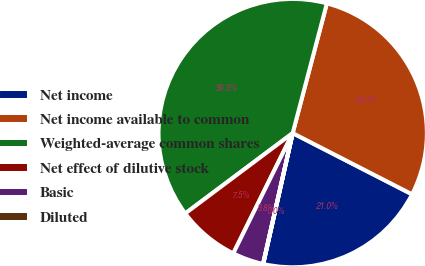Convert chart. <chart><loc_0><loc_0><loc_500><loc_500><pie_chart><fcel>Net income<fcel>Net income available to common<fcel>Weighted-average common shares<fcel>Net effect of dilutive stock<fcel>Basic<fcel>Diluted<nl><fcel>20.98%<fcel>28.44%<fcel>39.32%<fcel>7.48%<fcel>3.75%<fcel>0.03%<nl></chart> 